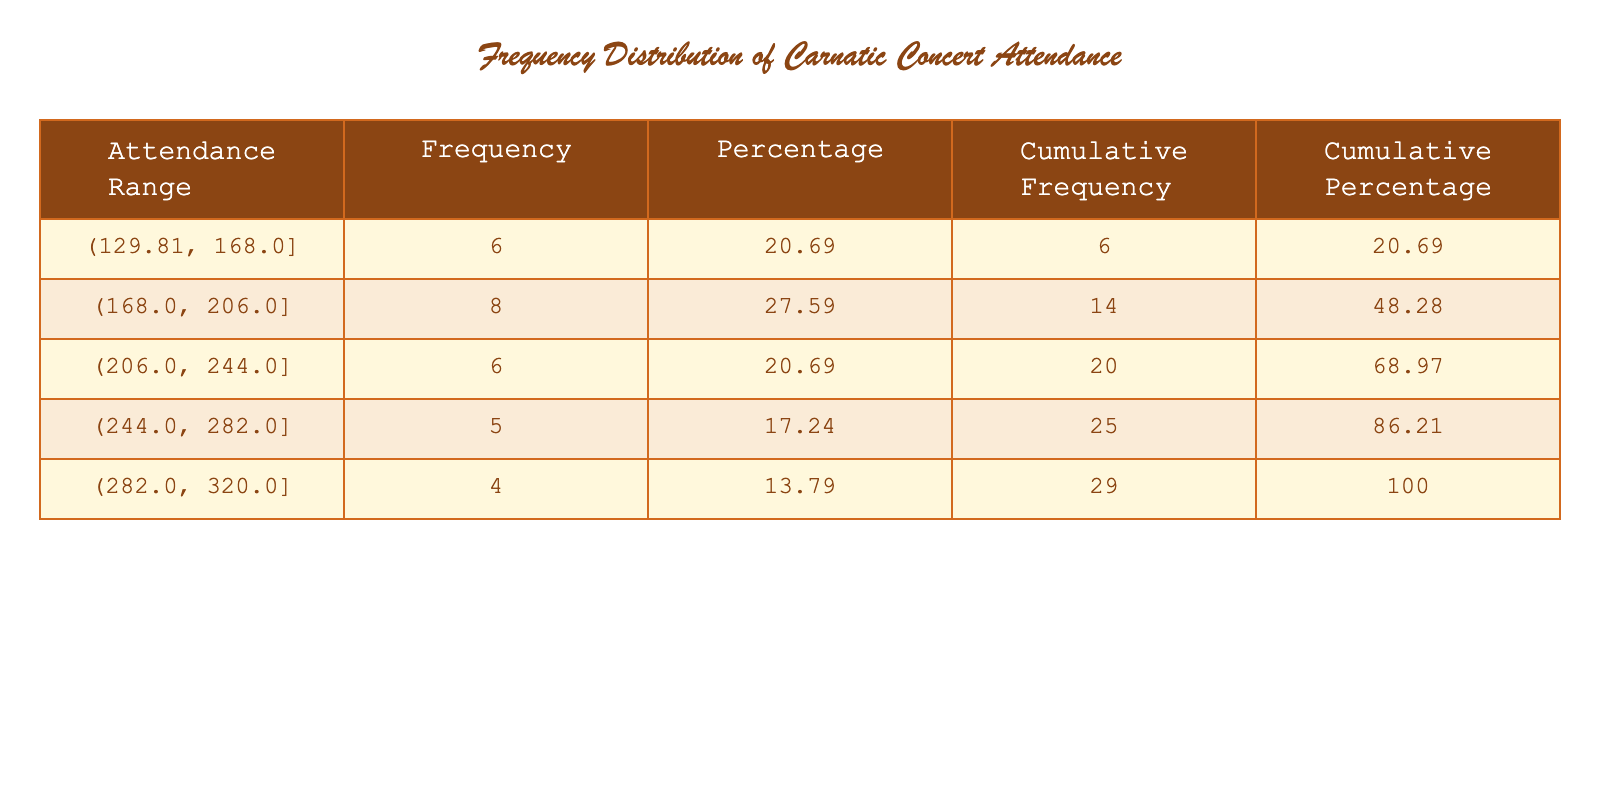What is the range of attendance frequencies in the table? The table shows attendance ranges in the "Attendance Range" column. The lowest range is 130-160, and the highest is 300-320. Therefore, the overall range is 130 to 320.
Answer: 130 to 320 How many concerts had attendance frequencies between 200 and 250? By checking the "Frequency" column for attendance ranges that include 200 to 250, we find two ranges: 200-240 and 240-300. The frequencies for these ranges are 6 total concerts.
Answer: 6 What is the attendance frequency percentage for the range 200-240? The "Percentage" for the range of 200-240 is listed in the table as 30.77. This is calculated by dividing the frequency of this range by the total concerts (6/39) and multiplying by 100.
Answer: 30.77 Did any concert have an attendance frequency of exactly 150? Looking through the table, we can see that there is a specific entry with an attendance frequency of 150, confirming that the answer is yes.
Answer: Yes What is the cumulative percentage of attendance frequencies by the last entry in the table? To find the cumulative percentage, we look at the "Cumulative Percentage" column for the last entry, which represents all concerts combined. The cumulative percentage is 100.
Answer: 100 How many concerts had attendance frequencies above the average attendance frequency? First, we calculate the average attendance frequency using the total attendance frequencies (sum of all entries) divided by the number of concerts (39). The average is 230. This average shows that there are 16 concerts with attendance frequencies above this average.
Answer: 16 What is the difference in attendance frequency between the highest and the lowest range? The table shows the highest frequency at 320 and the lowest at 130. To find the difference, we subtract the lowest from the highest: 320 - 130 = 190.
Answer: 190 How many concerts had attendance frequencies below 200? We look for ranges that are below 200, which include 130-160, 160-180, and 180-200. Adding up the frequencies for these ranges gives us a total of 15 concerts.
Answer: 15 What is the total attendance frequency for concerts held in March? We need to consider the attendance frequencies for concerts in March: 220, 300, and 160. Summing these gives us 220 + 300 + 160 = 680 for the total attendance in March.
Answer: 680 